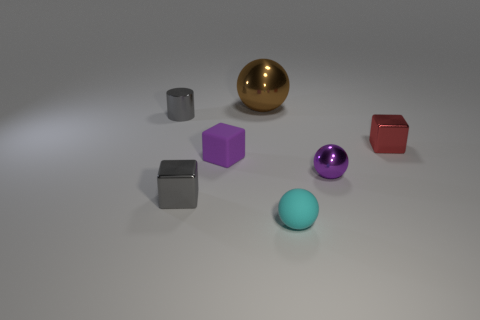The metal cube in front of the metal cube on the right side of the small cyan rubber object is what color?
Your answer should be compact. Gray. How many other objects are the same material as the purple cube?
Offer a terse response. 1. How many metal things are either tiny red things or purple cubes?
Offer a very short reply. 1. What is the color of the other tiny shiny object that is the same shape as the tiny red thing?
Provide a short and direct response. Gray. How many things are tiny shiny objects or large red matte things?
Provide a short and direct response. 4. What is the shape of the tiny purple object that is made of the same material as the cyan thing?
Provide a short and direct response. Cube. What number of tiny objects are either red spheres or brown metal objects?
Provide a succinct answer. 0. What number of other objects are the same color as the rubber cube?
Your answer should be compact. 1. There is a tiny shiny cube that is on the right side of the tiny rubber object in front of the rubber cube; what number of tiny metal blocks are in front of it?
Your answer should be very brief. 1. Is the size of the gray thing that is behind the gray cube the same as the large sphere?
Provide a succinct answer. No. 